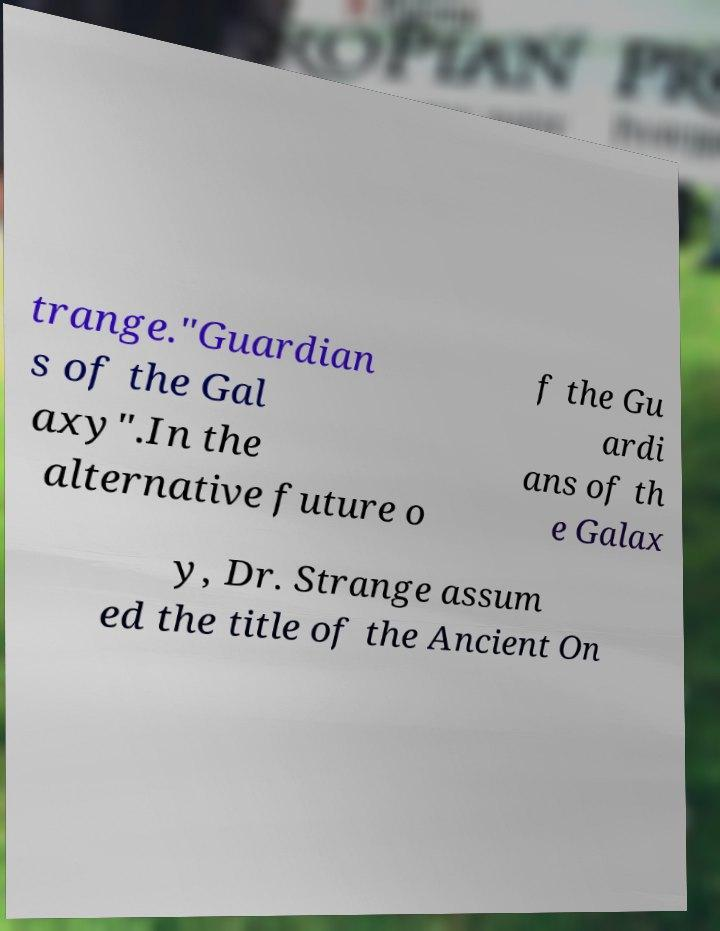Please read and relay the text visible in this image. What does it say? trange."Guardian s of the Gal axy".In the alternative future o f the Gu ardi ans of th e Galax y, Dr. Strange assum ed the title of the Ancient On 